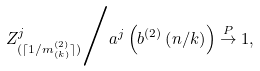Convert formula to latex. <formula><loc_0><loc_0><loc_500><loc_500>Z ^ { j } _ { ( \lceil 1 / m ^ { ( 2 ) } _ { ( k ) } \rceil ) } { \Big { / } } a ^ { j } \left ( b ^ { ( 2 ) } \left ( n / k \right ) \right ) \stackrel { P } { \rightarrow } 1 ,</formula> 